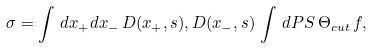<formula> <loc_0><loc_0><loc_500><loc_500>\sigma = \int \, d x _ { + } d x _ { - } \, D ( x _ { + } , s ) , D ( x _ { - } , s ) \, \int \, d P S \, \Theta _ { c u t } \, f ,</formula> 